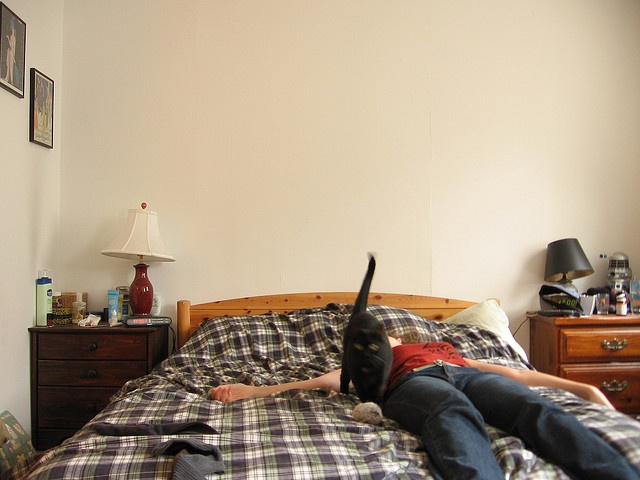Describe the objects in this image and their specific colors. I can see bed in tan, gray, black, and darkgray tones, people in tan, black, gray, salmon, and darkblue tones, cat in tan, black, and gray tones, clock in tan, black, gray, and darkgray tones, and cup in tan, gray, darkgray, and maroon tones in this image. 